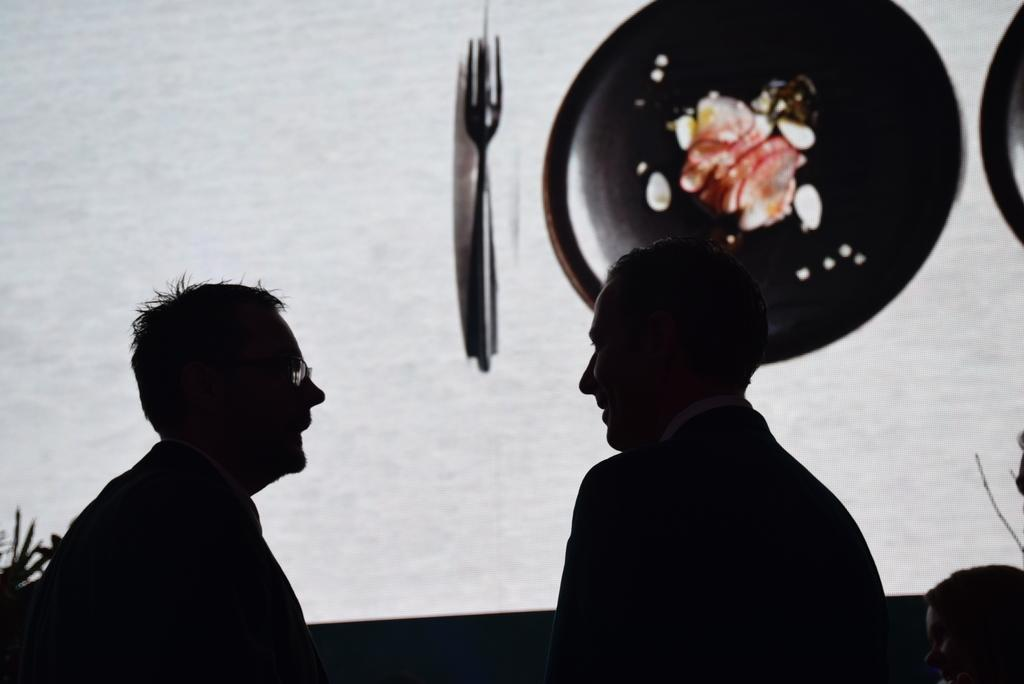What type of living organisms can be seen in the image? Plants are visible in the image. How many people are present in the image? There are two people standing in the image. What is the woman in the image doing? The woman is sitting near the wall in the image. Can you describe any utensils visible in the image? There is a fork visible in the image. What decorative items can be seen on the wall in the image? There are two plates hanging on the wall in the image. What type of breakfast is being prepared in the image? There is no indication of breakfast being prepared in the image. What is the position of the drain in the image? There is no drain present in the image. 